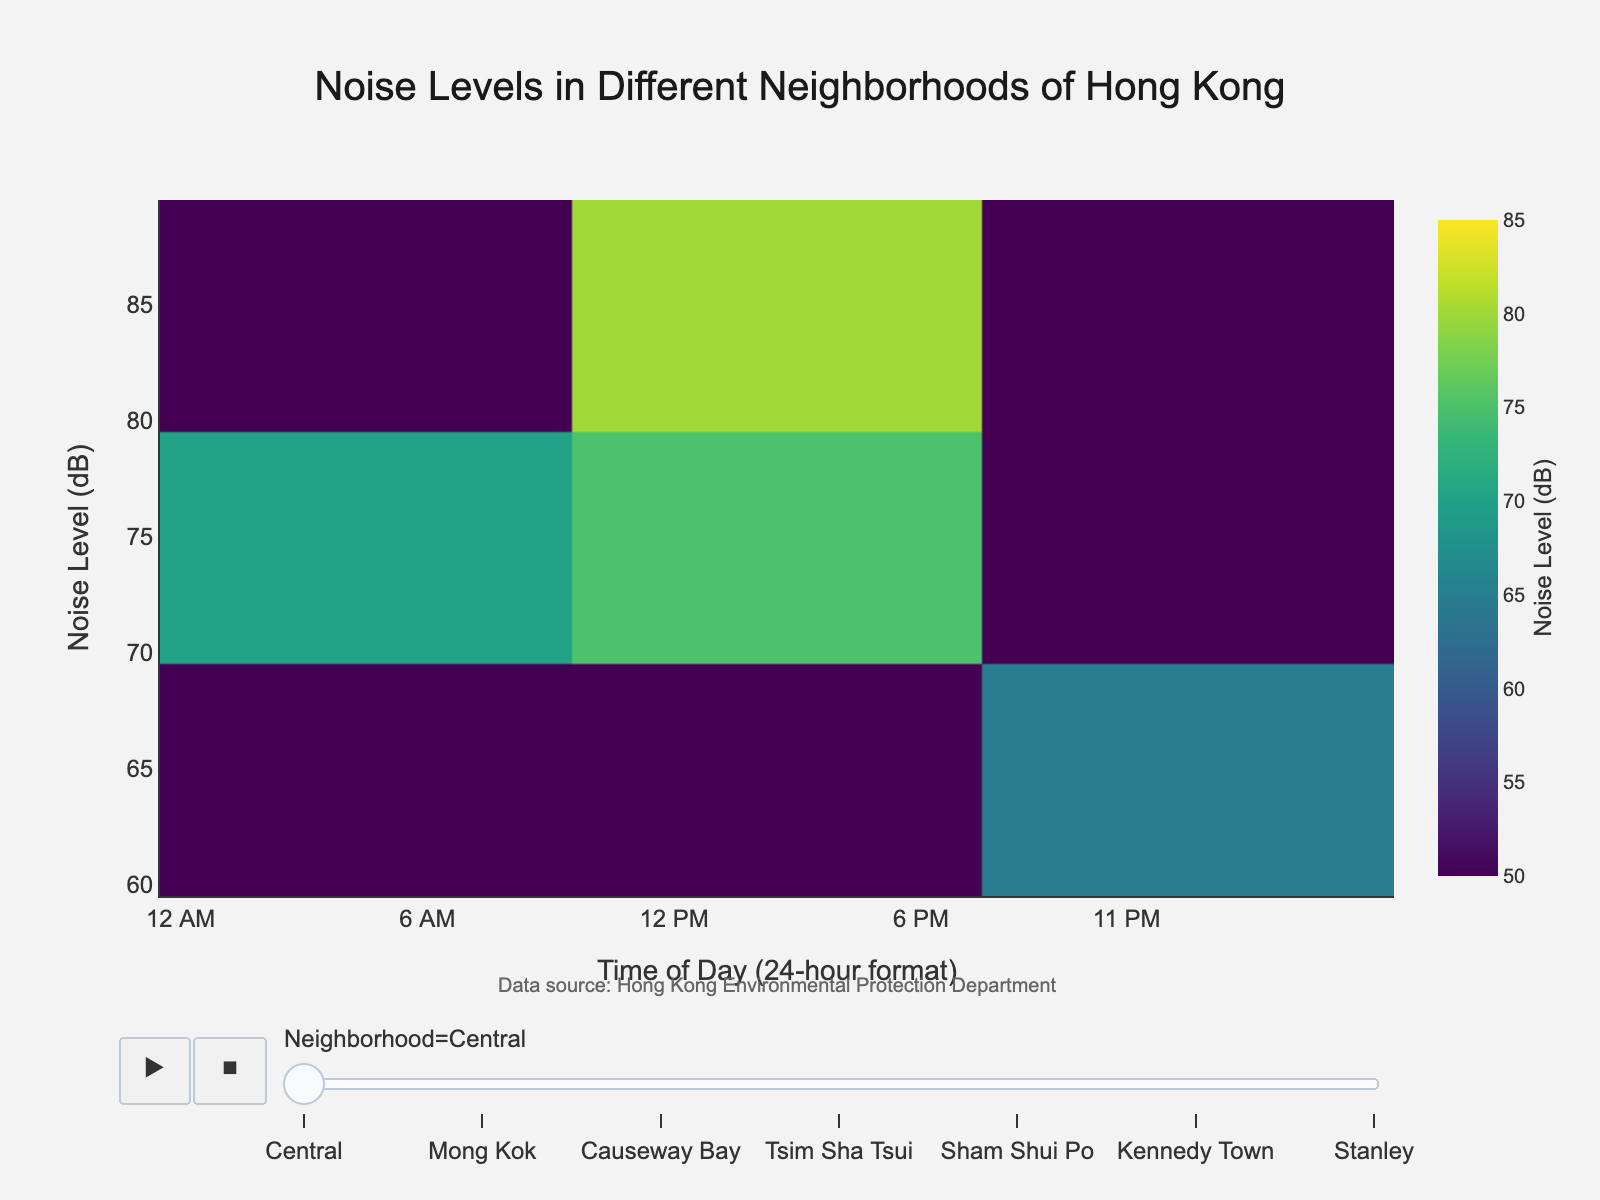Which neighborhood has the highest noise level at 6:00 PM? Look at the noise levels for each neighborhood at 6:00 PM and identify the highest value. Mong Kok has the highest noise level of 85 dB at 6:00 PM, which is the peak noise level among all neighborhoods.
Answer: Mong Kok What's the general trend of noise levels throughout the day in Kennedy Town? Check the density plot for Kennedy Town and observe the change in noise levels over different times of the day (8:00 AM, 12:00 PM, 6:00 PM, 10:00 PM). The noise levels in Kennedy Town gradually increase from 60 dB at 8:00 AM and peak at 70 dB at 6:00 PM, before dropping to 55 dB at 10:00 PM.
Answer: Increase then decrease At what time of day is the noise level the highest in Causeway Bay? Refer to the plot for Causeway Bay and identify the time of day when the noise level reaches its maximum value. The highest noise level in Causeway Bay is 78 dB, which occurs at 6:00 PM.
Answer: 6:00 PM Which neighborhood consistently has the lowest noise levels throughout the day? Compare the noise levels of all neighborhoods across different times of the day. Stanley consistently has the lowest noise levels, ranging from 50 dB at 10:00 PM to 65 dB at 6:00 PM.
Answer: Stanley How does the noise level in Central at 10:00 PM compare to that in Tsim Sha Tsui at the same time? Observe the noise levels in Central and Tsim Sha Tsui at 10:00 PM on the density plot. Central has a noise level of 65 dB at 10:00 PM, whereas Tsim Sha Tsui has a noise level of 66 dB at the same time.
Answer: Central is slightly quieter Which time of day has the highest average noise level across all neighborhoods? Calculate the average noise level for each time of day across all neighborhoods and compare these averages. The highest average noise level occurs at 6:00 PM, as it is the peak time for most neighborhoods followed by notable higher values.
Answer: 6:00 PM What is the difference in noise levels between Sham Shui Po and Kennedy Town at 12:00 PM? Identify the noise levels at 12:00 PM for both Sham Shui Po (70 dB) and Kennedy Town (65 dB) and compute the difference. The difference in noise levels is 70 dB - 65 dB = 5 dB.
Answer: 5 dB Does Mong Kok have consistently higher noise levels than Stanly at all times of the day? Compare the noise levels in Mong Kok and Stanley for each specified time. Mong Kok exhibits consistently higher noise levels (ranging from 68 dB to 85 dB) compared to Stanley (ranging from 50 dB to 65 dB) at all times.
Answer: Yes What is the typical noise range in Central throughout the day? Review the noise levels in Central at different times and determine the minimum and maximum values to establish the typical range. The noise levels in Central range from a minimum of 65 dB at 10:00 PM to a maximum of 80 dB at 6:00 PM.
Answer: 65 dB to 80 dB 